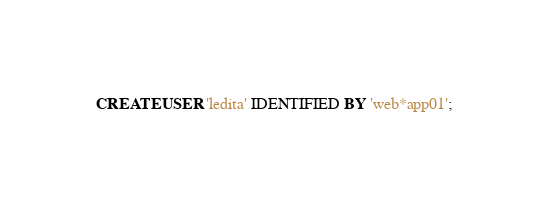Convert code to text. <code><loc_0><loc_0><loc_500><loc_500><_SQL_>CREATE USER 'ledita' IDENTIFIED BY 'web*app01';</code> 